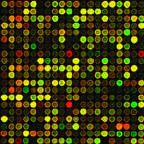what is being utilized to identify mutations that can be targeted by drugs?
Answer the question using a single word or phrase. Genetic analysis of cancers 